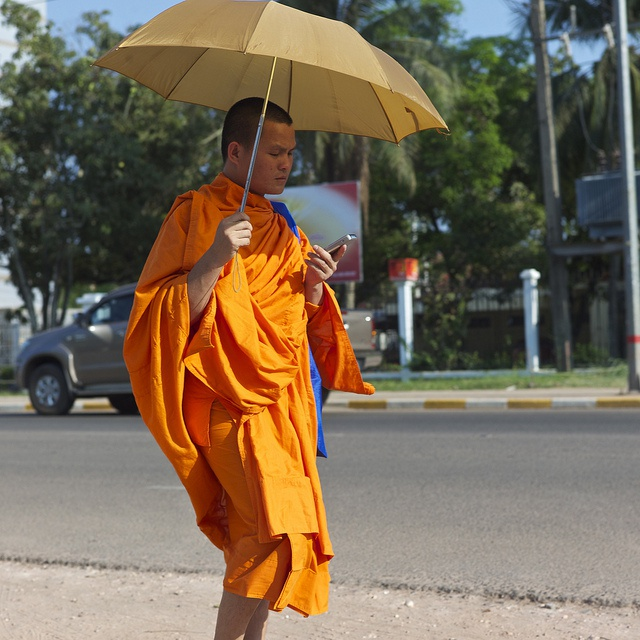Describe the objects in this image and their specific colors. I can see people in lightblue, maroon, orange, and brown tones, umbrella in lightgray, olive, and tan tones, truck in lightblue, black, gray, and darkblue tones, handbag in lightblue, blue, and navy tones, and cell phone in lightgray, gray, black, maroon, and darkgray tones in this image. 